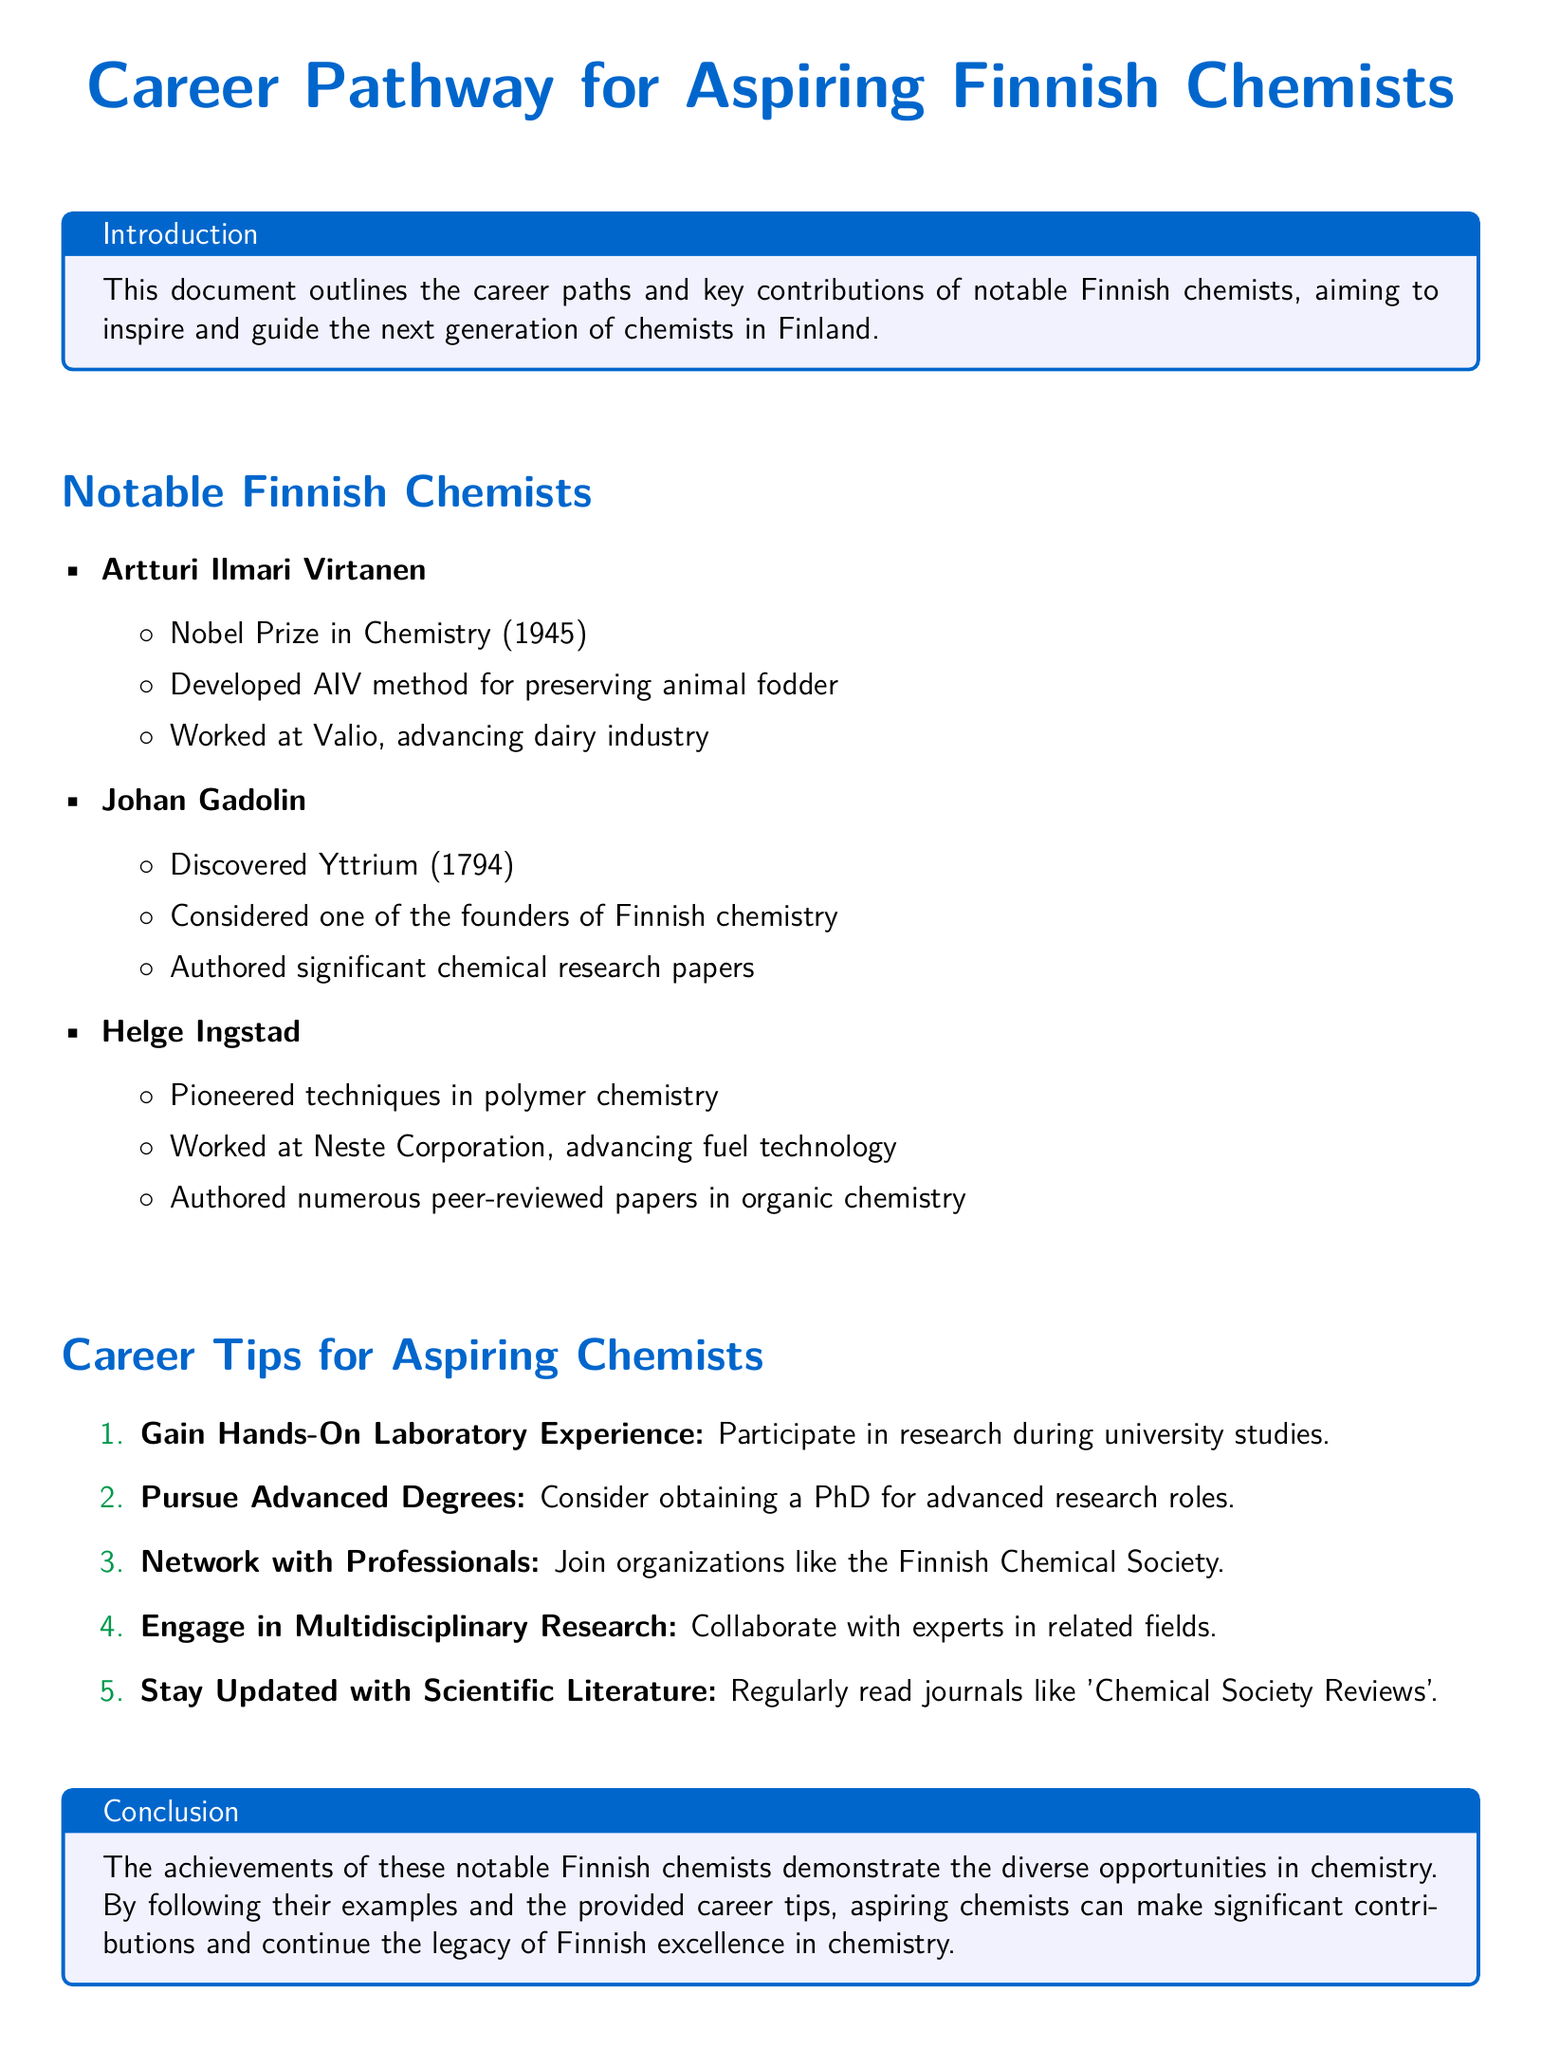What is the title of the document? The title of the document is highlighted at the top and summarizes the content regarding career pathways in chemistry.
Answer: Career Pathway for Aspiring Finnish Chemists Who won the Nobel Prize in Chemistry in 1945? The document lists Artturi Ilmari Virtanen as the Nobel laureate in Chemistry from Finland for that year.
Answer: Artturi Ilmari Virtanen Which key method did Artturi Ilmari Virtanen develop? The document specifies that he developed the AIV method for preserving animal fodder.
Answer: AIV method In what year was Yttrium discovered? The document states that Johan Gadolin discovered Yttrium in 1794.
Answer: 1794 What organization is mentioned for networking opportunities? The document suggests joining the Finnish Chemical Society for professional networking in chemistry.
Answer: Finnish Chemical Society Which Finnish chemist is considered one of the founders of Finnish chemistry? The document mentions Johan Gadolin regarding his foundational contributions to Finnish chemistry.
Answer: Johan Gadolin What is one career tip provided in the document? The document enumerates several career tips, including gaining hands-on laboratory experience as a starter.
Answer: Gain Hands-On Laboratory Experience How many notable Finnish chemists are listed? By counting the instances in the document, it can be determined that there are three notable Finnish chemists mentioned.
Answer: Three What type of literature should aspiring chemists stay updated with? The document advises that aspiring chemists read scientific journals, specifically naming 'Chemical Society Reviews'.
Answer: Chemical Society Reviews 